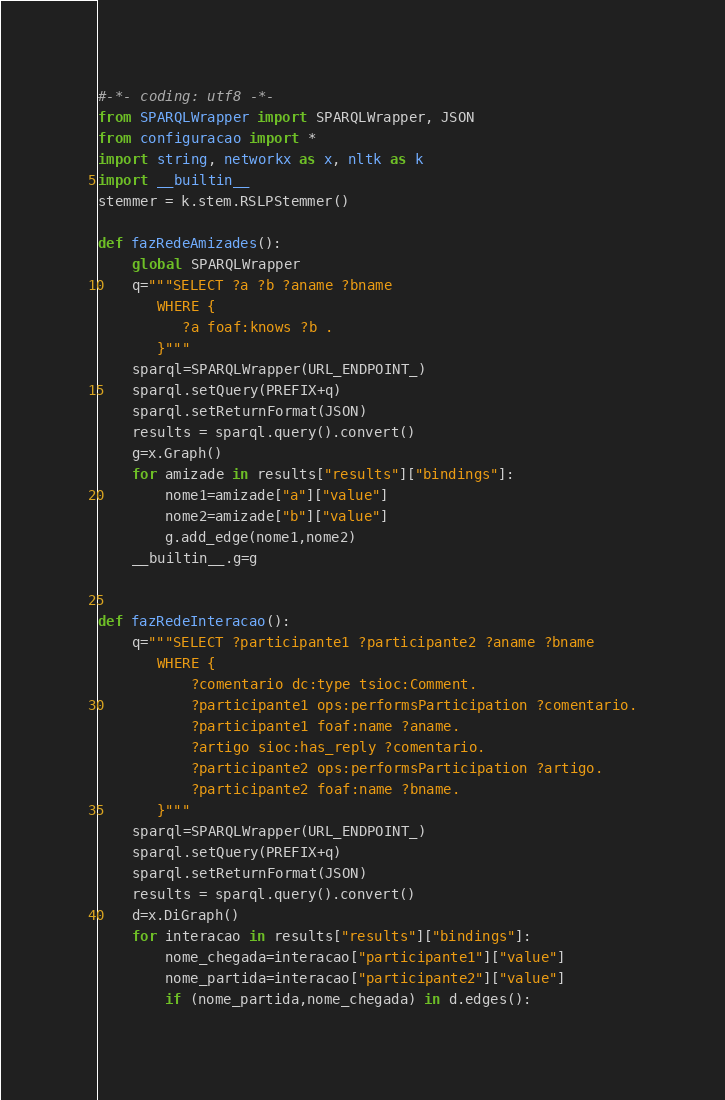Convert code to text. <code><loc_0><loc_0><loc_500><loc_500><_Python_>#-*- coding: utf8 -*-
from SPARQLWrapper import SPARQLWrapper, JSON
from configuracao import *
import string, networkx as x, nltk as k
import __builtin__
stemmer = k.stem.RSLPStemmer()

def fazRedeAmizades():
    global SPARQLWrapper
    q="""SELECT ?a ?b ?aname ?bname
       WHERE {
          ?a foaf:knows ?b .
       }"""
    sparql=SPARQLWrapper(URL_ENDPOINT_)
    sparql.setQuery(PREFIX+q)
    sparql.setReturnFormat(JSON)
    results = sparql.query().convert()
    g=x.Graph()
    for amizade in results["results"]["bindings"]:
        nome1=amizade["a"]["value"]
        nome2=amizade["b"]["value"]
        g.add_edge(nome1,nome2)
    __builtin__.g=g


def fazRedeInteracao():
    q="""SELECT ?participante1 ?participante2 ?aname ?bname
       WHERE {
           ?comentario dc:type tsioc:Comment.
           ?participante1 ops:performsParticipation ?comentario.
           ?participante1 foaf:name ?aname.
           ?artigo sioc:has_reply ?comentario.
           ?participante2 ops:performsParticipation ?artigo.
           ?participante2 foaf:name ?bname.
       }"""
    sparql=SPARQLWrapper(URL_ENDPOINT_)
    sparql.setQuery(PREFIX+q)
    sparql.setReturnFormat(JSON)
    results = sparql.query().convert()
    d=x.DiGraph()
    for interacao in results["results"]["bindings"]:
        nome_chegada=interacao["participante1"]["value"]
        nome_partida=interacao["participante2"]["value"]
        if (nome_partida,nome_chegada) in d.edges():</code> 